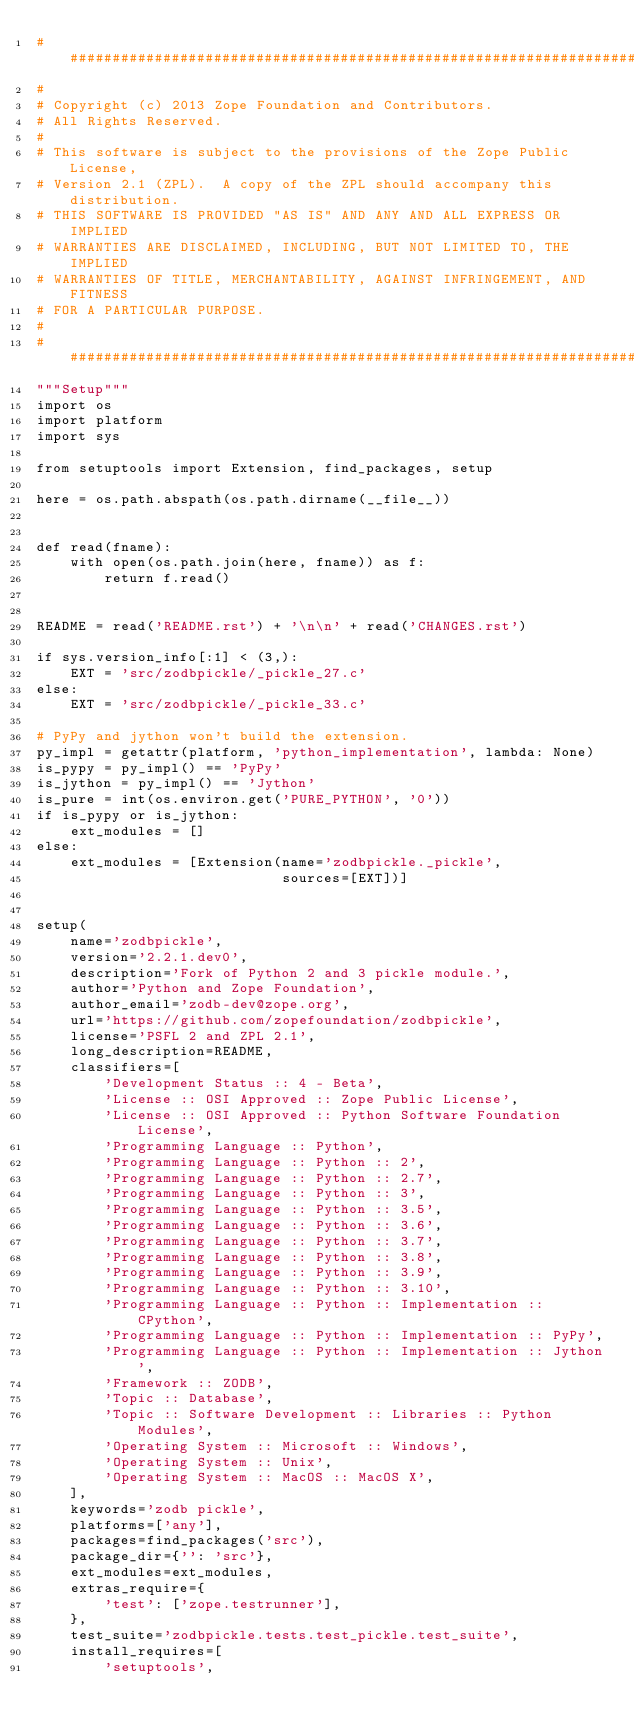Convert code to text. <code><loc_0><loc_0><loc_500><loc_500><_Python_>##############################################################################
#
# Copyright (c) 2013 Zope Foundation and Contributors.
# All Rights Reserved.
#
# This software is subject to the provisions of the Zope Public License,
# Version 2.1 (ZPL).  A copy of the ZPL should accompany this distribution.
# THIS SOFTWARE IS PROVIDED "AS IS" AND ANY AND ALL EXPRESS OR IMPLIED
# WARRANTIES ARE DISCLAIMED, INCLUDING, BUT NOT LIMITED TO, THE IMPLIED
# WARRANTIES OF TITLE, MERCHANTABILITY, AGAINST INFRINGEMENT, AND FITNESS
# FOR A PARTICULAR PURPOSE.
#
##############################################################################
"""Setup"""
import os
import platform
import sys

from setuptools import Extension, find_packages, setup

here = os.path.abspath(os.path.dirname(__file__))


def read(fname):
    with open(os.path.join(here, fname)) as f:
        return f.read()


README = read('README.rst') + '\n\n' + read('CHANGES.rst')

if sys.version_info[:1] < (3,):
    EXT = 'src/zodbpickle/_pickle_27.c'
else:
    EXT = 'src/zodbpickle/_pickle_33.c'

# PyPy and jython won't build the extension.
py_impl = getattr(platform, 'python_implementation', lambda: None)
is_pypy = py_impl() == 'PyPy'
is_jython = py_impl() == 'Jython'
is_pure = int(os.environ.get('PURE_PYTHON', '0'))
if is_pypy or is_jython:
    ext_modules = []
else:
    ext_modules = [Extension(name='zodbpickle._pickle',
                             sources=[EXT])]


setup(
    name='zodbpickle',
    version='2.2.1.dev0',
    description='Fork of Python 2 and 3 pickle module.',
    author='Python and Zope Foundation',
    author_email='zodb-dev@zope.org',
    url='https://github.com/zopefoundation/zodbpickle',
    license='PSFL 2 and ZPL 2.1',
    long_description=README,
    classifiers=[
        'Development Status :: 4 - Beta',
        'License :: OSI Approved :: Zope Public License',
        'License :: OSI Approved :: Python Software Foundation License',
        'Programming Language :: Python',
        'Programming Language :: Python :: 2',
        'Programming Language :: Python :: 2.7',
        'Programming Language :: Python :: 3',
        'Programming Language :: Python :: 3.5',
        'Programming Language :: Python :: 3.6',
        'Programming Language :: Python :: 3.7',
        'Programming Language :: Python :: 3.8',
        'Programming Language :: Python :: 3.9',
        'Programming Language :: Python :: 3.10',
        'Programming Language :: Python :: Implementation :: CPython',
        'Programming Language :: Python :: Implementation :: PyPy',
        'Programming Language :: Python :: Implementation :: Jython',
        'Framework :: ZODB',
        'Topic :: Database',
        'Topic :: Software Development :: Libraries :: Python Modules',
        'Operating System :: Microsoft :: Windows',
        'Operating System :: Unix',
        'Operating System :: MacOS :: MacOS X',
    ],
    keywords='zodb pickle',
    platforms=['any'],
    packages=find_packages('src'),
    package_dir={'': 'src'},
    ext_modules=ext_modules,
    extras_require={
        'test': ['zope.testrunner'],
    },
    test_suite='zodbpickle.tests.test_pickle.test_suite',
    install_requires=[
        'setuptools',</code> 